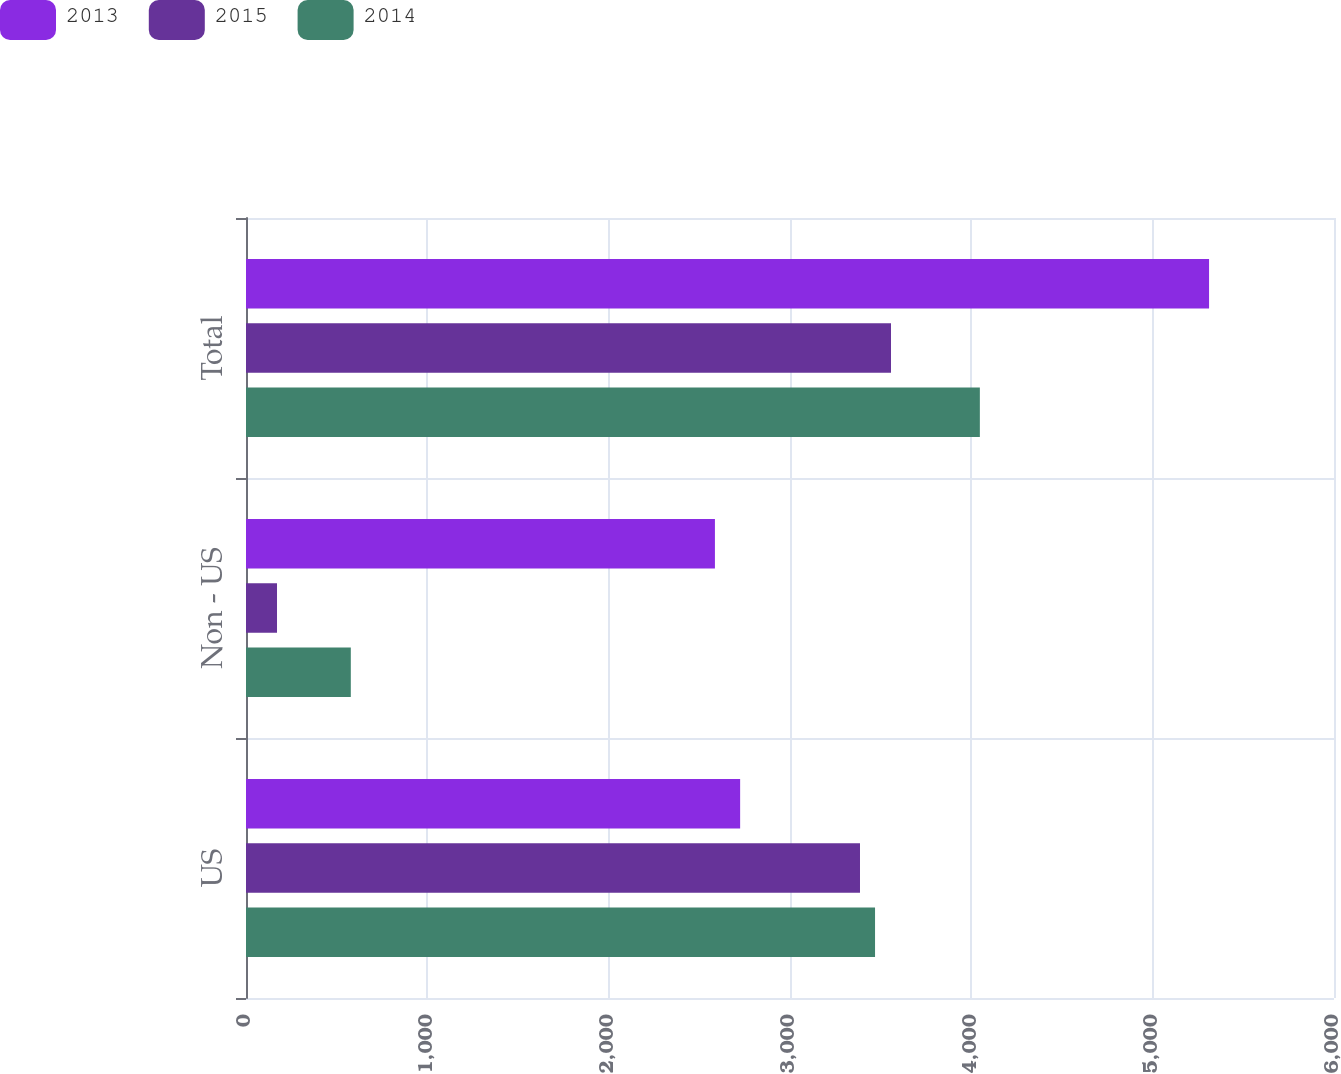Convert chart to OTSL. <chart><loc_0><loc_0><loc_500><loc_500><stacked_bar_chart><ecel><fcel>US<fcel>Non - US<fcel>Total<nl><fcel>2013<fcel>2725<fcel>2586<fcel>5311<nl><fcel>2015<fcel>3386<fcel>171<fcel>3557<nl><fcel>2014<fcel>3469<fcel>578<fcel>4047<nl></chart> 